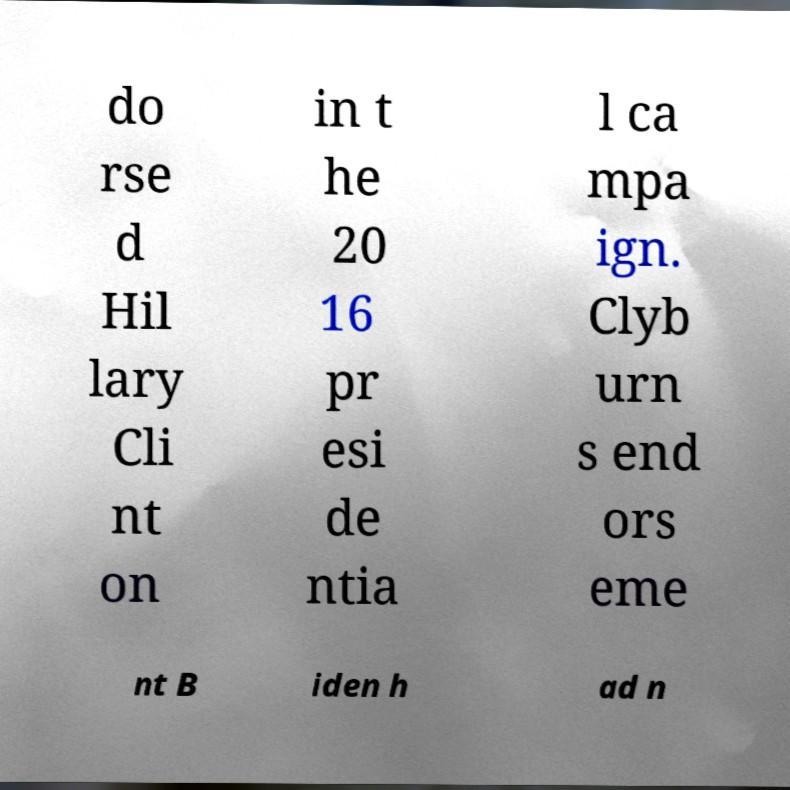Please read and relay the text visible in this image. What does it say? do rse d Hil lary Cli nt on in t he 20 16 pr esi de ntia l ca mpa ign. Clyb urn s end ors eme nt B iden h ad n 